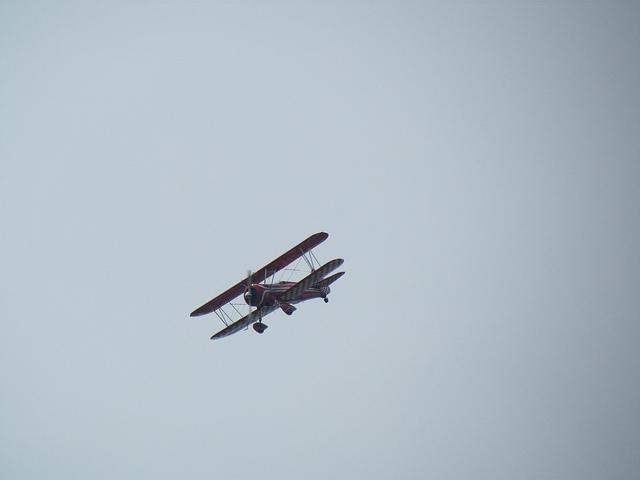How many tires does the plane have?
Answer briefly. 3. What kind of aircraft is this?
Answer briefly. Plane. Is this a propeller plane?
Keep it brief. Yes. Is this moving fast?
Short answer required. Yes. How many engines are on the plane?
Concise answer only. 1. How has aviation transformed human migration?
Keep it brief. Make it fast. Are the jets for military or private use?
Short answer required. Private. Is the plane upside down?
Answer briefly. No. Why is the plane upside down?
Quick response, please. It is not. What kind of plane is this?
Give a very brief answer. Biplane. Are the propeller planes?
Answer briefly. Yes. Why is the photo blurry?
Give a very brief answer. It's not. How many planes are in the sky?
Keep it brief. 1. What side of the airplane is facing the camera?
Answer briefly. Front. How many engines does this plane have?
Keep it brief. 1. Is this a chair?
Concise answer only. No. How many planes are there?
Concise answer only. 1. How many main engines does this vehicle have?
Write a very short answer. 1. How many planes are in the picture?
Answer briefly. 1. Is the plane flying straight?
Short answer required. No. What type of aircraft is this?
Concise answer only. Plane. What does the sky look like?
Give a very brief answer. Gray. What color is the plane?
Give a very brief answer. Red. Is this a commercial airplane?
Write a very short answer. No. Does this plane have jet engines?
Write a very short answer. No. How many objects are in this photo?
Answer briefly. 1. What is in the air?
Concise answer only. Plane. 